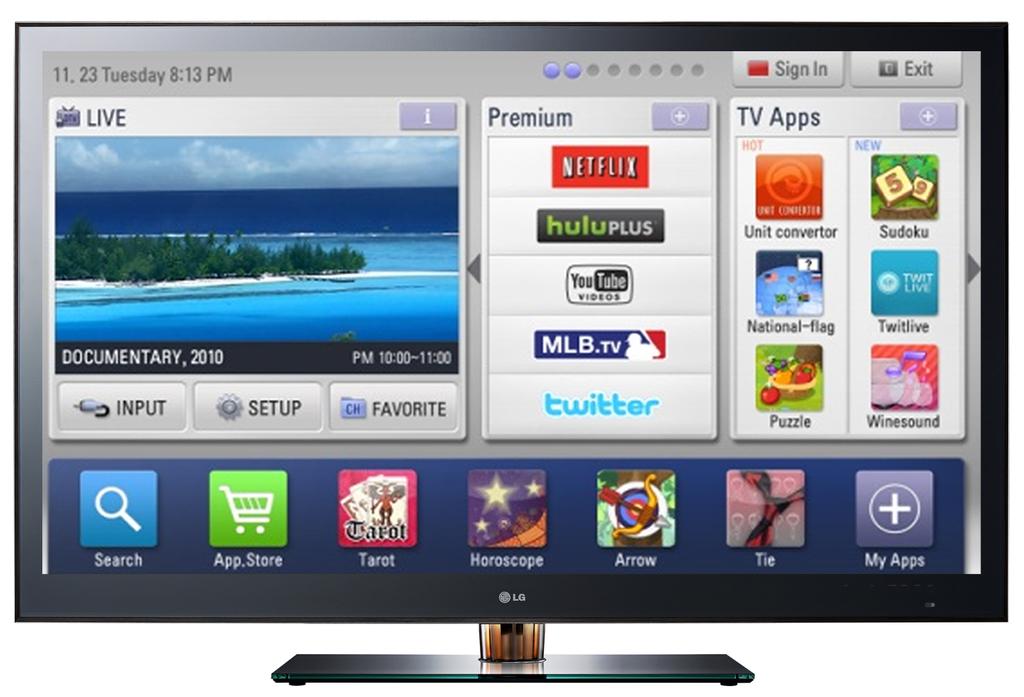What year is shown below the troipical picture?
Your response must be concise. 2010. 